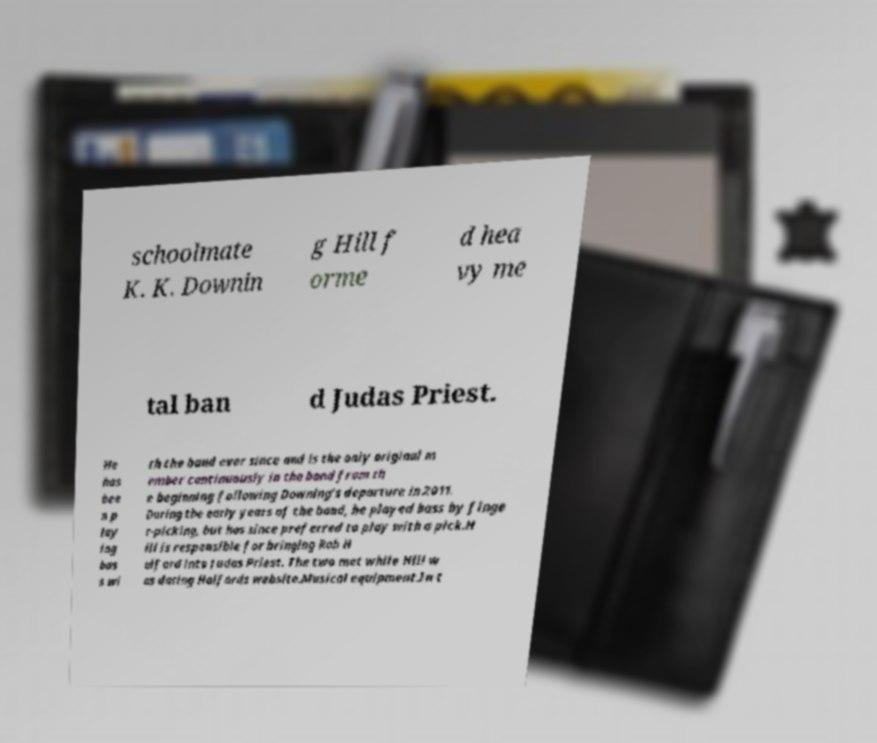Please identify and transcribe the text found in this image. schoolmate K. K. Downin g Hill f orme d hea vy me tal ban d Judas Priest. He has bee n p lay ing bas s wi th the band ever since and is the only original m ember continuously in the band from th e beginning following Downing's departure in 2011. During the early years of the band, he played bass by finge r-picking, but has since preferred to play with a pick.H ill is responsible for bringing Rob H alford into Judas Priest. The two met while Hill w as dating Halfords website.Musical equipment.In t 